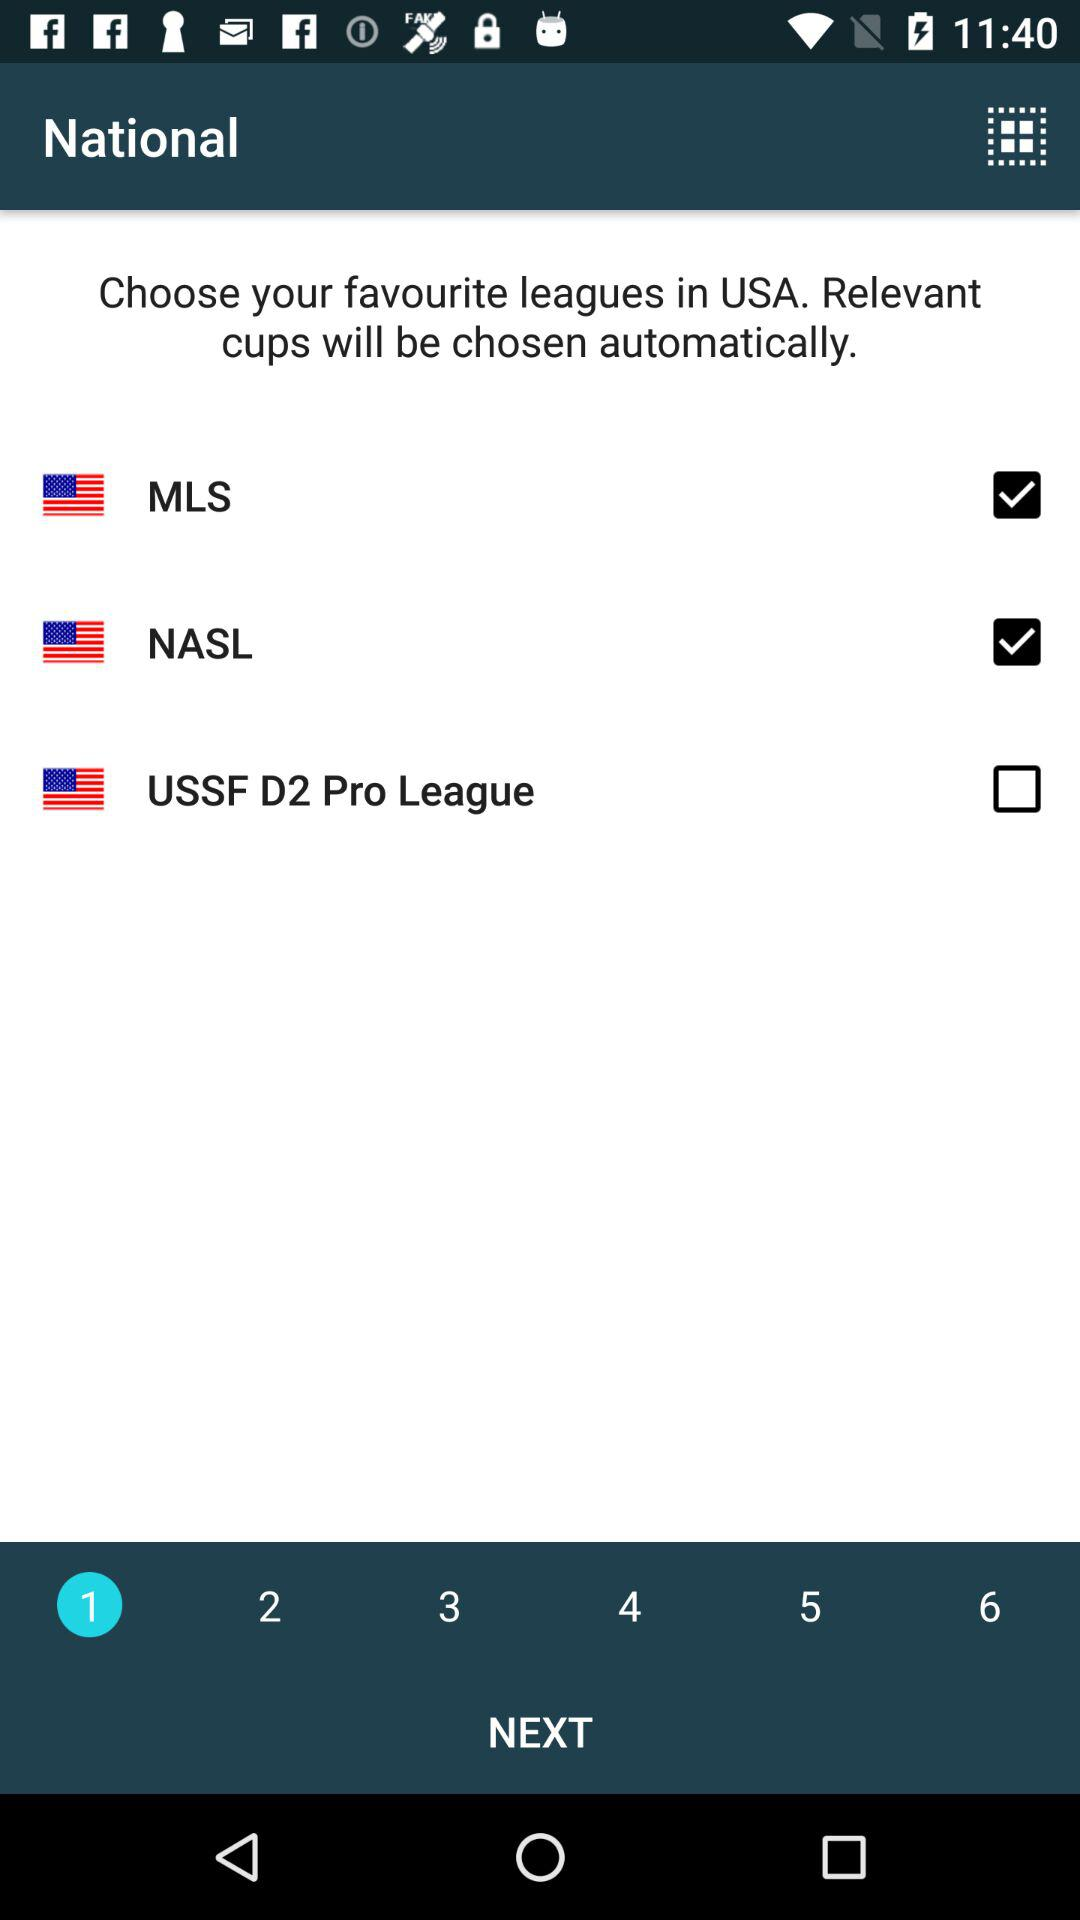What number is selected? The selected number is 1. 